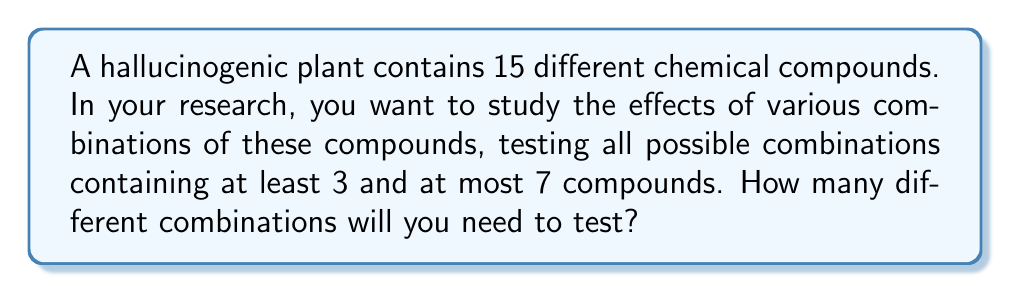Could you help me with this problem? Let's approach this step-by-step:

1) We need to calculate the sum of combinations from 3 to 7 compounds out of 15.

2) The formula for combinations is:
   $$C(n,r) = \frac{n!}{r!(n-r)!}$$
   where $n$ is the total number of items and $r$ is the number of items being chosen.

3) We need to calculate:
   $$C(15,3) + C(15,4) + C(15,5) + C(15,6) + C(15,7)$$

4) Let's calculate each term:

   $$C(15,3) = \frac{15!}{3!(15-3)!} = \frac{15!}{3!12!} = 455$$
   
   $$C(15,4) = \frac{15!}{4!(15-4)!} = \frac{15!}{4!11!} = 1365$$
   
   $$C(15,5) = \frac{15!}{5!(15-5)!} = \frac{15!}{5!10!} = 3003$$
   
   $$C(15,6) = \frac{15!}{6!(15-6)!} = \frac{15!}{6!9!} = 5005$$
   
   $$C(15,7) = \frac{15!}{7!(15-7)!} = \frac{15!}{7!8!} = 6435$$

5) Now, we sum these values:
   $$455 + 1365 + 3003 + 5005 + 6435 = 16263$$

Therefore, you will need to test 16,263 different combinations.
Answer: 16,263 combinations 